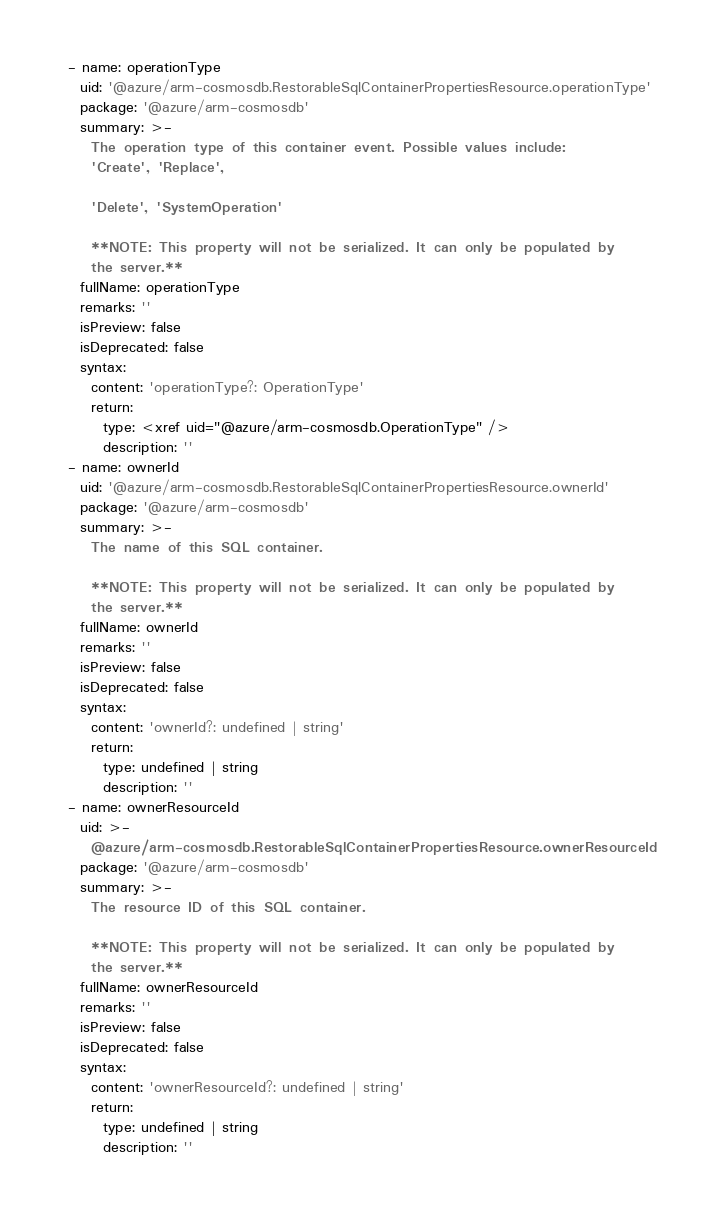Convert code to text. <code><loc_0><loc_0><loc_500><loc_500><_YAML_>  - name: operationType
    uid: '@azure/arm-cosmosdb.RestorableSqlContainerPropertiesResource.operationType'
    package: '@azure/arm-cosmosdb'
    summary: >-
      The operation type of this container event. Possible values include:
      'Create', 'Replace',

      'Delete', 'SystemOperation'

      **NOTE: This property will not be serialized. It can only be populated by
      the server.**
    fullName: operationType
    remarks: ''
    isPreview: false
    isDeprecated: false
    syntax:
      content: 'operationType?: OperationType'
      return:
        type: <xref uid="@azure/arm-cosmosdb.OperationType" />
        description: ''
  - name: ownerId
    uid: '@azure/arm-cosmosdb.RestorableSqlContainerPropertiesResource.ownerId'
    package: '@azure/arm-cosmosdb'
    summary: >-
      The name of this SQL container.

      **NOTE: This property will not be serialized. It can only be populated by
      the server.**
    fullName: ownerId
    remarks: ''
    isPreview: false
    isDeprecated: false
    syntax:
      content: 'ownerId?: undefined | string'
      return:
        type: undefined | string
        description: ''
  - name: ownerResourceId
    uid: >-
      @azure/arm-cosmosdb.RestorableSqlContainerPropertiesResource.ownerResourceId
    package: '@azure/arm-cosmosdb'
    summary: >-
      The resource ID of this SQL container.

      **NOTE: This property will not be serialized. It can only be populated by
      the server.**
    fullName: ownerResourceId
    remarks: ''
    isPreview: false
    isDeprecated: false
    syntax:
      content: 'ownerResourceId?: undefined | string'
      return:
        type: undefined | string
        description: ''
</code> 